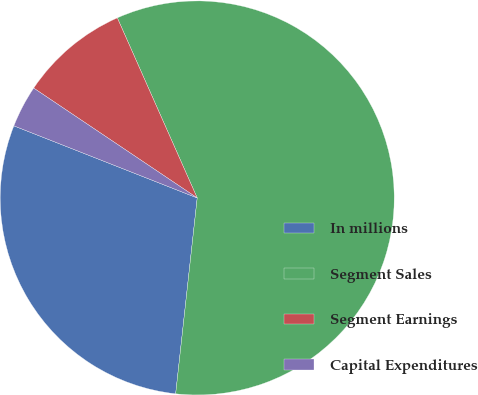Convert chart. <chart><loc_0><loc_0><loc_500><loc_500><pie_chart><fcel>In millions<fcel>Segment Sales<fcel>Segment Earnings<fcel>Capital Expenditures<nl><fcel>29.22%<fcel>58.39%<fcel>8.94%<fcel>3.45%<nl></chart> 